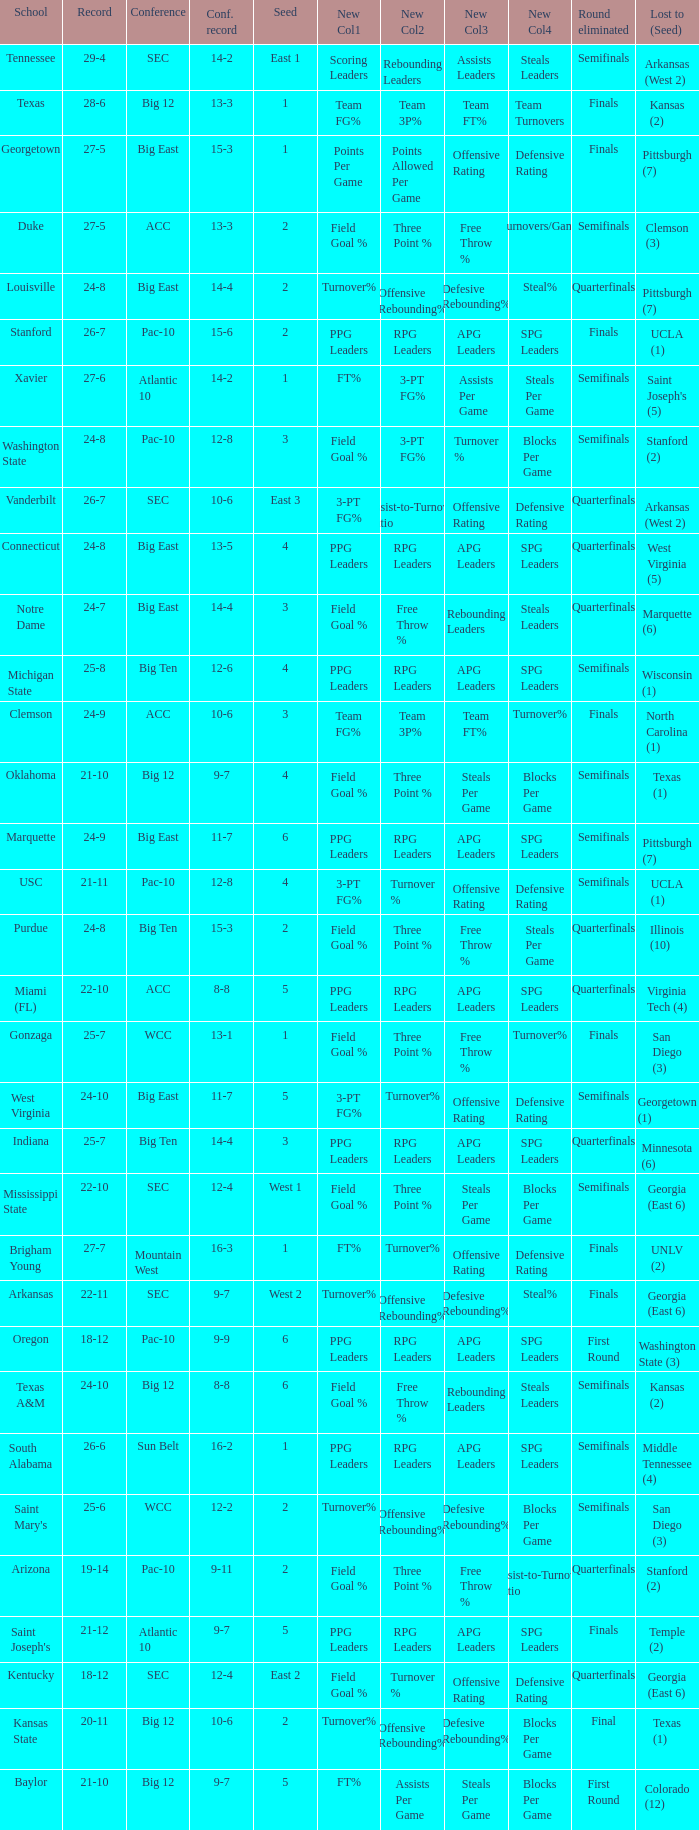Name the conference record where seed is 3 and record is 24-9 10-6. 